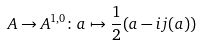<formula> <loc_0><loc_0><loc_500><loc_500>A \to A ^ { 1 , 0 } \colon a \mapsto \frac { 1 } { 2 } ( a - i j ( a ) )</formula> 